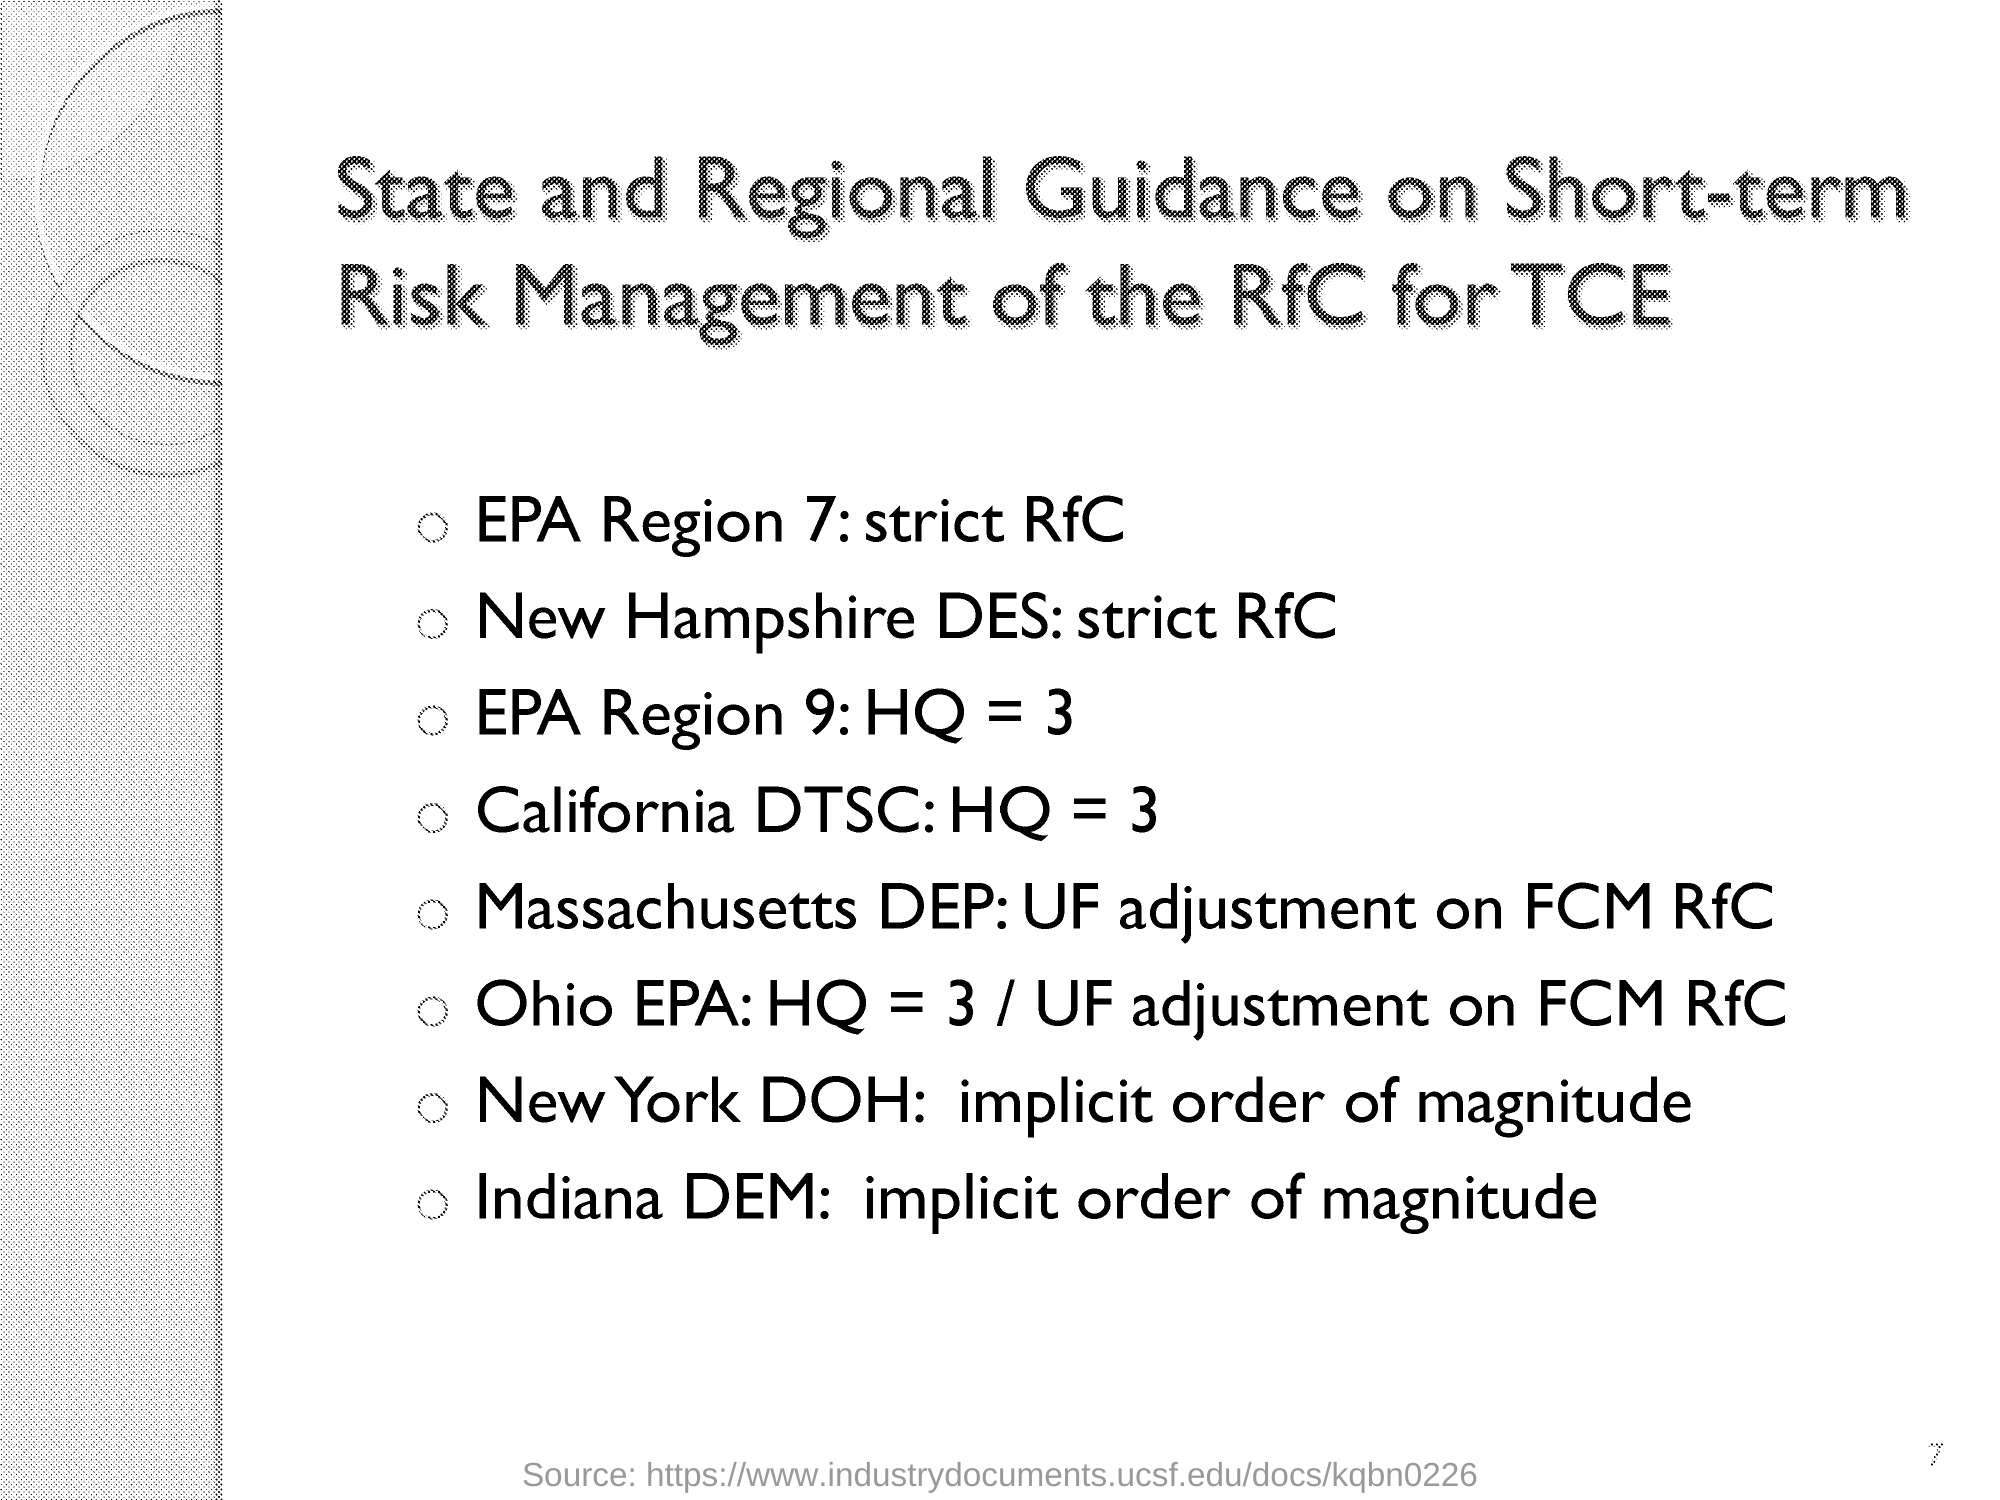Specify some key components in this picture. The management of EPA Region 7 should adhere to the guidelines outlined in 'State and Regional Guidance on Short-term Risk Management' for safe and effective risk management practices, as recommended by the EPA Region 7 Strict RfC. The Indiana Dam Emergency Management should be managed according to the State and Regional Guidance on Short-term Risk Management, in accordance with industry standards and best practices. It is recommended that the New York Department of Health be managed in accordance with the state and regional guidance on short-term risk management, as outlined in the implicit order of magnitude. The first region mentioned in the "State and Regional Guidance on Short-term Risk Management of the RfC for TCE" is EPA Region 7. The management of 'New Hampshire DES' should adhere to the guidelines set forth in 'State and Regional Guidance on Short-term Risk Management,' specifically the recommendation for a strict RfC. 